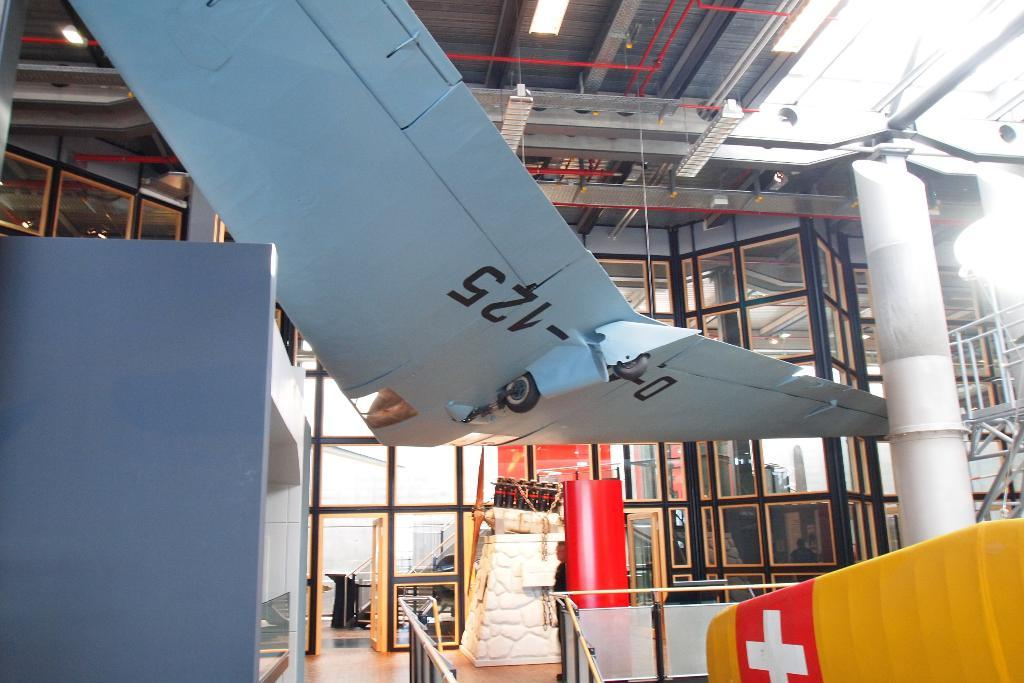What type of doors are located in the middle of the image? There are glass doors in the middle of the image. Can you describe the object on the top of the image? Unfortunately, the provided facts do not give any information about the object on the top of the image. What type of business is being conducted in the image? The provided facts do not give any information about a business or any activity being conducted in the image. 